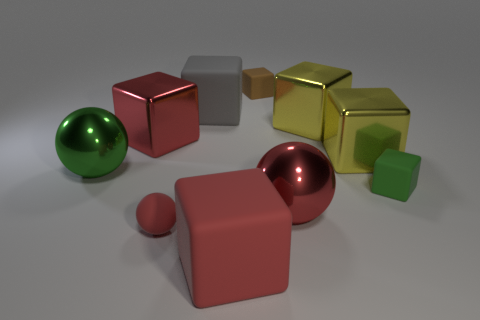What number of other objects are there of the same material as the green block?
Make the answer very short. 4. Are there more big green metal things than large yellow objects?
Your answer should be compact. No. There is a rubber object right of the small brown block; is it the same shape as the small red object?
Give a very brief answer. No. Are there fewer big gray metallic cylinders than green spheres?
Offer a very short reply. Yes. There is a green thing that is the same size as the brown block; what is it made of?
Your answer should be very brief. Rubber. There is a small ball; is it the same color as the tiny block that is on the left side of the tiny green rubber thing?
Ensure brevity in your answer.  No. Are there fewer big red spheres that are left of the large red sphere than big red matte objects?
Make the answer very short. Yes. What number of tiny green matte cubes are there?
Your answer should be very brief. 1. What is the shape of the big object in front of the big red thing to the right of the tiny brown matte cube?
Ensure brevity in your answer.  Cube. There is a small green matte object; how many big red matte objects are behind it?
Make the answer very short. 0. 